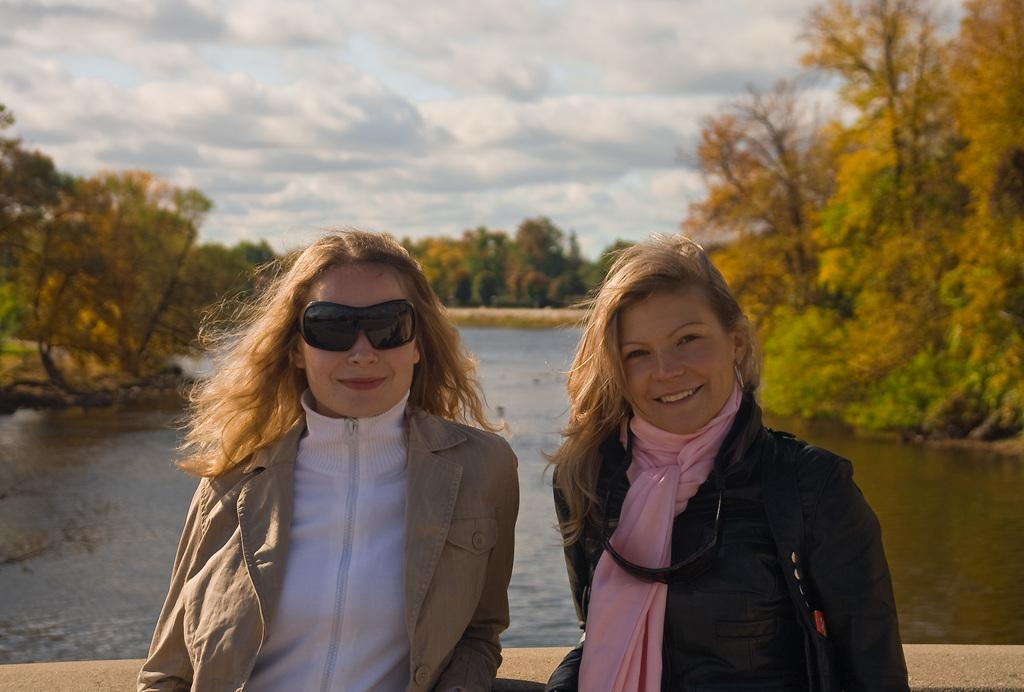How many women are in the image? There are two women in the image. What are the women wearing? The women are wearing clothes. What expression do the women have? The women are smiling. What company's logo is present in the image? There is a Google logo in the image. What natural element can be seen in the image? Water and trees are visible in the image. How would you describe the weather based on the image? The sky is cloudy in the image. What grade did the women receive for their performance in the image? There is no indication of a performance or grading system in the image. What type of punishment is being administered to the women in the image? There is no punishment being administered to the women in the image. 